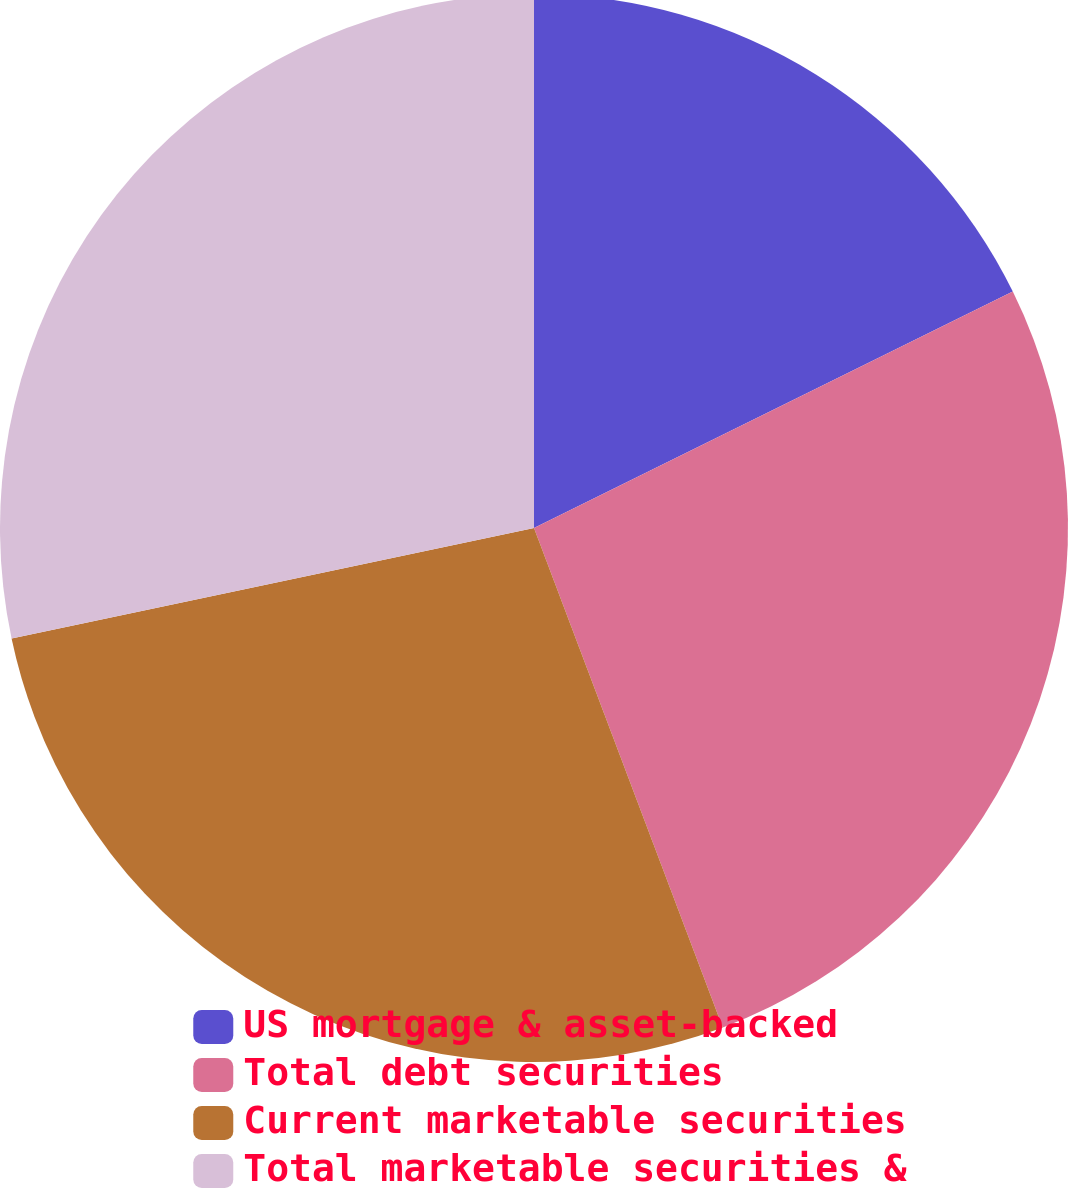Convert chart to OTSL. <chart><loc_0><loc_0><loc_500><loc_500><pie_chart><fcel>US mortgage & asset-backed<fcel>Total debt securities<fcel>Current marketable securities<fcel>Total marketable securities &<nl><fcel>17.7%<fcel>26.55%<fcel>27.43%<fcel>28.32%<nl></chart> 